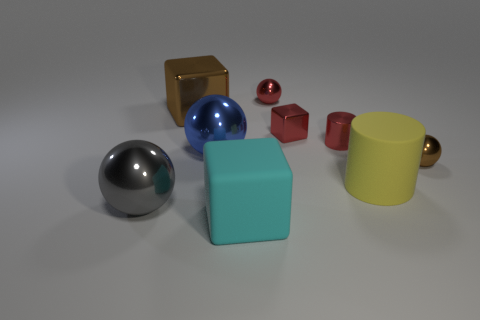Subtract all red balls. How many balls are left? 3 Add 1 big yellow objects. How many objects exist? 10 Subtract all brown spheres. How many spheres are left? 3 Subtract all cylinders. How many objects are left? 7 Add 1 tiny brown things. How many tiny brown things exist? 2 Subtract 0 purple blocks. How many objects are left? 9 Subtract all gray balls. Subtract all cyan cubes. How many balls are left? 3 Subtract all big gray metallic things. Subtract all tiny red things. How many objects are left? 5 Add 5 large yellow things. How many large yellow things are left? 6 